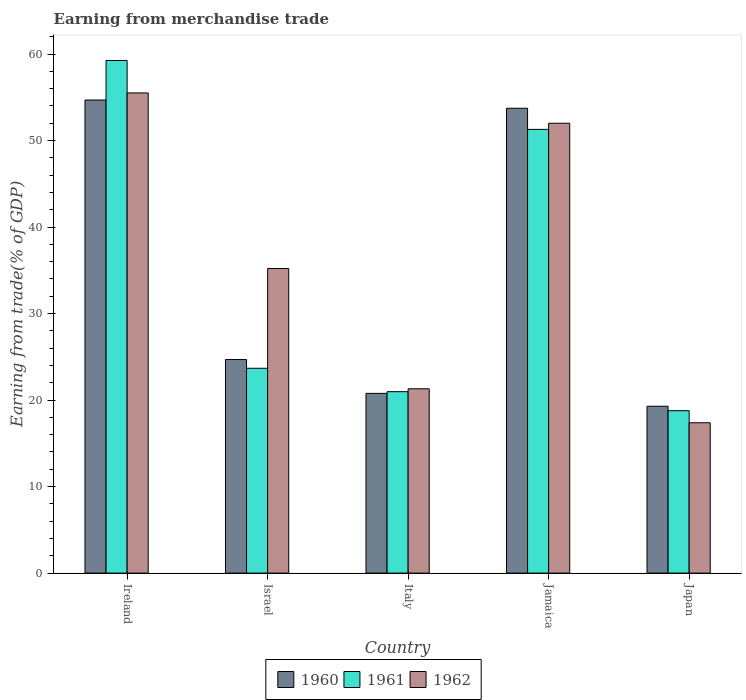How many different coloured bars are there?
Offer a terse response. 3. How many groups of bars are there?
Make the answer very short. 5. How many bars are there on the 4th tick from the left?
Provide a short and direct response. 3. In how many cases, is the number of bars for a given country not equal to the number of legend labels?
Make the answer very short. 0. What is the earnings from trade in 1962 in Israel?
Give a very brief answer. 35.21. Across all countries, what is the maximum earnings from trade in 1961?
Your answer should be compact. 59.26. Across all countries, what is the minimum earnings from trade in 1961?
Offer a terse response. 18.77. In which country was the earnings from trade in 1962 maximum?
Ensure brevity in your answer.  Ireland. What is the total earnings from trade in 1961 in the graph?
Offer a terse response. 173.98. What is the difference between the earnings from trade in 1961 in Italy and that in Japan?
Your response must be concise. 2.2. What is the difference between the earnings from trade in 1960 in Italy and the earnings from trade in 1962 in Japan?
Make the answer very short. 3.4. What is the average earnings from trade in 1962 per country?
Your response must be concise. 36.28. What is the difference between the earnings from trade of/in 1960 and earnings from trade of/in 1962 in Ireland?
Make the answer very short. -0.82. What is the ratio of the earnings from trade in 1961 in Ireland to that in Japan?
Provide a succinct answer. 3.16. What is the difference between the highest and the second highest earnings from trade in 1960?
Make the answer very short. -29.05. What is the difference between the highest and the lowest earnings from trade in 1960?
Offer a terse response. 35.4. Is the sum of the earnings from trade in 1961 in Italy and Jamaica greater than the maximum earnings from trade in 1962 across all countries?
Your response must be concise. Yes. What does the 2nd bar from the right in Japan represents?
Offer a very short reply. 1961. Is it the case that in every country, the sum of the earnings from trade in 1960 and earnings from trade in 1962 is greater than the earnings from trade in 1961?
Ensure brevity in your answer.  Yes. How many bars are there?
Offer a terse response. 15. How many countries are there in the graph?
Your response must be concise. 5. What is the difference between two consecutive major ticks on the Y-axis?
Your answer should be very brief. 10. Are the values on the major ticks of Y-axis written in scientific E-notation?
Keep it short and to the point. No. Where does the legend appear in the graph?
Keep it short and to the point. Bottom center. How many legend labels are there?
Provide a succinct answer. 3. How are the legend labels stacked?
Your answer should be compact. Horizontal. What is the title of the graph?
Offer a terse response. Earning from merchandise trade. Does "1992" appear as one of the legend labels in the graph?
Offer a terse response. No. What is the label or title of the Y-axis?
Your response must be concise. Earning from trade(% of GDP). What is the Earning from trade(% of GDP) in 1960 in Ireland?
Keep it short and to the point. 54.69. What is the Earning from trade(% of GDP) in 1961 in Ireland?
Make the answer very short. 59.26. What is the Earning from trade(% of GDP) in 1962 in Ireland?
Your answer should be compact. 55.51. What is the Earning from trade(% of GDP) in 1960 in Israel?
Offer a very short reply. 24.69. What is the Earning from trade(% of GDP) in 1961 in Israel?
Your answer should be compact. 23.68. What is the Earning from trade(% of GDP) in 1962 in Israel?
Provide a short and direct response. 35.21. What is the Earning from trade(% of GDP) of 1960 in Italy?
Keep it short and to the point. 20.78. What is the Earning from trade(% of GDP) of 1961 in Italy?
Make the answer very short. 20.97. What is the Earning from trade(% of GDP) of 1962 in Italy?
Ensure brevity in your answer.  21.31. What is the Earning from trade(% of GDP) in 1960 in Jamaica?
Keep it short and to the point. 53.74. What is the Earning from trade(% of GDP) in 1961 in Jamaica?
Ensure brevity in your answer.  51.3. What is the Earning from trade(% of GDP) of 1962 in Jamaica?
Your answer should be compact. 52. What is the Earning from trade(% of GDP) of 1960 in Japan?
Your response must be concise. 19.29. What is the Earning from trade(% of GDP) of 1961 in Japan?
Give a very brief answer. 18.77. What is the Earning from trade(% of GDP) of 1962 in Japan?
Make the answer very short. 17.38. Across all countries, what is the maximum Earning from trade(% of GDP) of 1960?
Offer a very short reply. 54.69. Across all countries, what is the maximum Earning from trade(% of GDP) of 1961?
Give a very brief answer. 59.26. Across all countries, what is the maximum Earning from trade(% of GDP) of 1962?
Offer a terse response. 55.51. Across all countries, what is the minimum Earning from trade(% of GDP) of 1960?
Offer a terse response. 19.29. Across all countries, what is the minimum Earning from trade(% of GDP) in 1961?
Give a very brief answer. 18.77. Across all countries, what is the minimum Earning from trade(% of GDP) in 1962?
Ensure brevity in your answer.  17.38. What is the total Earning from trade(% of GDP) in 1960 in the graph?
Provide a succinct answer. 173.18. What is the total Earning from trade(% of GDP) in 1961 in the graph?
Your answer should be compact. 173.98. What is the total Earning from trade(% of GDP) in 1962 in the graph?
Ensure brevity in your answer.  181.41. What is the difference between the Earning from trade(% of GDP) in 1960 in Ireland and that in Israel?
Give a very brief answer. 30. What is the difference between the Earning from trade(% of GDP) of 1961 in Ireland and that in Israel?
Make the answer very short. 35.58. What is the difference between the Earning from trade(% of GDP) in 1962 in Ireland and that in Israel?
Your response must be concise. 20.3. What is the difference between the Earning from trade(% of GDP) of 1960 in Ireland and that in Italy?
Your response must be concise. 33.91. What is the difference between the Earning from trade(% of GDP) of 1961 in Ireland and that in Italy?
Provide a short and direct response. 38.29. What is the difference between the Earning from trade(% of GDP) in 1962 in Ireland and that in Italy?
Your answer should be compact. 34.2. What is the difference between the Earning from trade(% of GDP) of 1960 in Ireland and that in Jamaica?
Your answer should be compact. 0.95. What is the difference between the Earning from trade(% of GDP) in 1961 in Ireland and that in Jamaica?
Make the answer very short. 7.96. What is the difference between the Earning from trade(% of GDP) of 1962 in Ireland and that in Jamaica?
Your answer should be very brief. 3.5. What is the difference between the Earning from trade(% of GDP) in 1960 in Ireland and that in Japan?
Offer a very short reply. 35.4. What is the difference between the Earning from trade(% of GDP) of 1961 in Ireland and that in Japan?
Give a very brief answer. 40.48. What is the difference between the Earning from trade(% of GDP) of 1962 in Ireland and that in Japan?
Keep it short and to the point. 38.13. What is the difference between the Earning from trade(% of GDP) of 1960 in Israel and that in Italy?
Offer a terse response. 3.91. What is the difference between the Earning from trade(% of GDP) of 1961 in Israel and that in Italy?
Give a very brief answer. 2.71. What is the difference between the Earning from trade(% of GDP) of 1962 in Israel and that in Italy?
Your answer should be compact. 13.9. What is the difference between the Earning from trade(% of GDP) of 1960 in Israel and that in Jamaica?
Make the answer very short. -29.05. What is the difference between the Earning from trade(% of GDP) of 1961 in Israel and that in Jamaica?
Make the answer very short. -27.62. What is the difference between the Earning from trade(% of GDP) of 1962 in Israel and that in Jamaica?
Ensure brevity in your answer.  -16.79. What is the difference between the Earning from trade(% of GDP) in 1960 in Israel and that in Japan?
Offer a very short reply. 5.4. What is the difference between the Earning from trade(% of GDP) in 1961 in Israel and that in Japan?
Provide a short and direct response. 4.9. What is the difference between the Earning from trade(% of GDP) of 1962 in Israel and that in Japan?
Keep it short and to the point. 17.83. What is the difference between the Earning from trade(% of GDP) of 1960 in Italy and that in Jamaica?
Offer a very short reply. -32.96. What is the difference between the Earning from trade(% of GDP) in 1961 in Italy and that in Jamaica?
Your response must be concise. -30.32. What is the difference between the Earning from trade(% of GDP) of 1962 in Italy and that in Jamaica?
Offer a terse response. -30.7. What is the difference between the Earning from trade(% of GDP) of 1960 in Italy and that in Japan?
Offer a very short reply. 1.49. What is the difference between the Earning from trade(% of GDP) of 1961 in Italy and that in Japan?
Provide a short and direct response. 2.2. What is the difference between the Earning from trade(% of GDP) of 1962 in Italy and that in Japan?
Provide a succinct answer. 3.93. What is the difference between the Earning from trade(% of GDP) of 1960 in Jamaica and that in Japan?
Offer a very short reply. 34.45. What is the difference between the Earning from trade(% of GDP) of 1961 in Jamaica and that in Japan?
Ensure brevity in your answer.  32.52. What is the difference between the Earning from trade(% of GDP) of 1962 in Jamaica and that in Japan?
Your answer should be very brief. 34.63. What is the difference between the Earning from trade(% of GDP) in 1960 in Ireland and the Earning from trade(% of GDP) in 1961 in Israel?
Keep it short and to the point. 31.01. What is the difference between the Earning from trade(% of GDP) in 1960 in Ireland and the Earning from trade(% of GDP) in 1962 in Israel?
Your answer should be compact. 19.48. What is the difference between the Earning from trade(% of GDP) in 1961 in Ireland and the Earning from trade(% of GDP) in 1962 in Israel?
Offer a terse response. 24.05. What is the difference between the Earning from trade(% of GDP) of 1960 in Ireland and the Earning from trade(% of GDP) of 1961 in Italy?
Keep it short and to the point. 33.72. What is the difference between the Earning from trade(% of GDP) in 1960 in Ireland and the Earning from trade(% of GDP) in 1962 in Italy?
Your answer should be compact. 33.38. What is the difference between the Earning from trade(% of GDP) of 1961 in Ireland and the Earning from trade(% of GDP) of 1962 in Italy?
Ensure brevity in your answer.  37.95. What is the difference between the Earning from trade(% of GDP) of 1960 in Ireland and the Earning from trade(% of GDP) of 1961 in Jamaica?
Give a very brief answer. 3.39. What is the difference between the Earning from trade(% of GDP) of 1960 in Ireland and the Earning from trade(% of GDP) of 1962 in Jamaica?
Give a very brief answer. 2.69. What is the difference between the Earning from trade(% of GDP) in 1961 in Ireland and the Earning from trade(% of GDP) in 1962 in Jamaica?
Provide a succinct answer. 7.25. What is the difference between the Earning from trade(% of GDP) in 1960 in Ireland and the Earning from trade(% of GDP) in 1961 in Japan?
Keep it short and to the point. 35.92. What is the difference between the Earning from trade(% of GDP) of 1960 in Ireland and the Earning from trade(% of GDP) of 1962 in Japan?
Provide a short and direct response. 37.31. What is the difference between the Earning from trade(% of GDP) in 1961 in Ireland and the Earning from trade(% of GDP) in 1962 in Japan?
Provide a succinct answer. 41.88. What is the difference between the Earning from trade(% of GDP) of 1960 in Israel and the Earning from trade(% of GDP) of 1961 in Italy?
Your answer should be very brief. 3.72. What is the difference between the Earning from trade(% of GDP) in 1960 in Israel and the Earning from trade(% of GDP) in 1962 in Italy?
Keep it short and to the point. 3.38. What is the difference between the Earning from trade(% of GDP) in 1961 in Israel and the Earning from trade(% of GDP) in 1962 in Italy?
Ensure brevity in your answer.  2.37. What is the difference between the Earning from trade(% of GDP) of 1960 in Israel and the Earning from trade(% of GDP) of 1961 in Jamaica?
Give a very brief answer. -26.61. What is the difference between the Earning from trade(% of GDP) in 1960 in Israel and the Earning from trade(% of GDP) in 1962 in Jamaica?
Give a very brief answer. -27.32. What is the difference between the Earning from trade(% of GDP) in 1961 in Israel and the Earning from trade(% of GDP) in 1962 in Jamaica?
Ensure brevity in your answer.  -28.33. What is the difference between the Earning from trade(% of GDP) of 1960 in Israel and the Earning from trade(% of GDP) of 1961 in Japan?
Provide a short and direct response. 5.91. What is the difference between the Earning from trade(% of GDP) in 1960 in Israel and the Earning from trade(% of GDP) in 1962 in Japan?
Keep it short and to the point. 7.31. What is the difference between the Earning from trade(% of GDP) in 1961 in Israel and the Earning from trade(% of GDP) in 1962 in Japan?
Offer a very short reply. 6.3. What is the difference between the Earning from trade(% of GDP) of 1960 in Italy and the Earning from trade(% of GDP) of 1961 in Jamaica?
Make the answer very short. -30.52. What is the difference between the Earning from trade(% of GDP) in 1960 in Italy and the Earning from trade(% of GDP) in 1962 in Jamaica?
Make the answer very short. -31.23. What is the difference between the Earning from trade(% of GDP) of 1961 in Italy and the Earning from trade(% of GDP) of 1962 in Jamaica?
Keep it short and to the point. -31.03. What is the difference between the Earning from trade(% of GDP) in 1960 in Italy and the Earning from trade(% of GDP) in 1961 in Japan?
Provide a succinct answer. 2. What is the difference between the Earning from trade(% of GDP) in 1960 in Italy and the Earning from trade(% of GDP) in 1962 in Japan?
Make the answer very short. 3.4. What is the difference between the Earning from trade(% of GDP) in 1961 in Italy and the Earning from trade(% of GDP) in 1962 in Japan?
Keep it short and to the point. 3.59. What is the difference between the Earning from trade(% of GDP) of 1960 in Jamaica and the Earning from trade(% of GDP) of 1961 in Japan?
Provide a short and direct response. 34.96. What is the difference between the Earning from trade(% of GDP) of 1960 in Jamaica and the Earning from trade(% of GDP) of 1962 in Japan?
Ensure brevity in your answer.  36.36. What is the difference between the Earning from trade(% of GDP) in 1961 in Jamaica and the Earning from trade(% of GDP) in 1962 in Japan?
Offer a terse response. 33.92. What is the average Earning from trade(% of GDP) of 1960 per country?
Ensure brevity in your answer.  34.64. What is the average Earning from trade(% of GDP) of 1961 per country?
Offer a terse response. 34.8. What is the average Earning from trade(% of GDP) of 1962 per country?
Offer a very short reply. 36.28. What is the difference between the Earning from trade(% of GDP) in 1960 and Earning from trade(% of GDP) in 1961 in Ireland?
Keep it short and to the point. -4.57. What is the difference between the Earning from trade(% of GDP) of 1960 and Earning from trade(% of GDP) of 1962 in Ireland?
Your response must be concise. -0.82. What is the difference between the Earning from trade(% of GDP) in 1961 and Earning from trade(% of GDP) in 1962 in Ireland?
Your answer should be very brief. 3.75. What is the difference between the Earning from trade(% of GDP) in 1960 and Earning from trade(% of GDP) in 1961 in Israel?
Give a very brief answer. 1.01. What is the difference between the Earning from trade(% of GDP) in 1960 and Earning from trade(% of GDP) in 1962 in Israel?
Keep it short and to the point. -10.52. What is the difference between the Earning from trade(% of GDP) of 1961 and Earning from trade(% of GDP) of 1962 in Israel?
Give a very brief answer. -11.53. What is the difference between the Earning from trade(% of GDP) of 1960 and Earning from trade(% of GDP) of 1961 in Italy?
Keep it short and to the point. -0.2. What is the difference between the Earning from trade(% of GDP) in 1960 and Earning from trade(% of GDP) in 1962 in Italy?
Make the answer very short. -0.53. What is the difference between the Earning from trade(% of GDP) of 1961 and Earning from trade(% of GDP) of 1962 in Italy?
Your response must be concise. -0.34. What is the difference between the Earning from trade(% of GDP) in 1960 and Earning from trade(% of GDP) in 1961 in Jamaica?
Offer a very short reply. 2.44. What is the difference between the Earning from trade(% of GDP) in 1960 and Earning from trade(% of GDP) in 1962 in Jamaica?
Offer a terse response. 1.73. What is the difference between the Earning from trade(% of GDP) of 1961 and Earning from trade(% of GDP) of 1962 in Jamaica?
Keep it short and to the point. -0.71. What is the difference between the Earning from trade(% of GDP) in 1960 and Earning from trade(% of GDP) in 1961 in Japan?
Give a very brief answer. 0.51. What is the difference between the Earning from trade(% of GDP) of 1960 and Earning from trade(% of GDP) of 1962 in Japan?
Provide a succinct answer. 1.91. What is the difference between the Earning from trade(% of GDP) of 1961 and Earning from trade(% of GDP) of 1962 in Japan?
Offer a terse response. 1.4. What is the ratio of the Earning from trade(% of GDP) of 1960 in Ireland to that in Israel?
Your response must be concise. 2.22. What is the ratio of the Earning from trade(% of GDP) in 1961 in Ireland to that in Israel?
Keep it short and to the point. 2.5. What is the ratio of the Earning from trade(% of GDP) in 1962 in Ireland to that in Israel?
Your answer should be compact. 1.58. What is the ratio of the Earning from trade(% of GDP) of 1960 in Ireland to that in Italy?
Your response must be concise. 2.63. What is the ratio of the Earning from trade(% of GDP) of 1961 in Ireland to that in Italy?
Your answer should be compact. 2.83. What is the ratio of the Earning from trade(% of GDP) in 1962 in Ireland to that in Italy?
Ensure brevity in your answer.  2.6. What is the ratio of the Earning from trade(% of GDP) of 1960 in Ireland to that in Jamaica?
Offer a terse response. 1.02. What is the ratio of the Earning from trade(% of GDP) in 1961 in Ireland to that in Jamaica?
Ensure brevity in your answer.  1.16. What is the ratio of the Earning from trade(% of GDP) of 1962 in Ireland to that in Jamaica?
Your answer should be very brief. 1.07. What is the ratio of the Earning from trade(% of GDP) in 1960 in Ireland to that in Japan?
Ensure brevity in your answer.  2.84. What is the ratio of the Earning from trade(% of GDP) of 1961 in Ireland to that in Japan?
Offer a very short reply. 3.16. What is the ratio of the Earning from trade(% of GDP) in 1962 in Ireland to that in Japan?
Offer a terse response. 3.19. What is the ratio of the Earning from trade(% of GDP) in 1960 in Israel to that in Italy?
Provide a short and direct response. 1.19. What is the ratio of the Earning from trade(% of GDP) of 1961 in Israel to that in Italy?
Provide a succinct answer. 1.13. What is the ratio of the Earning from trade(% of GDP) in 1962 in Israel to that in Italy?
Ensure brevity in your answer.  1.65. What is the ratio of the Earning from trade(% of GDP) in 1960 in Israel to that in Jamaica?
Offer a very short reply. 0.46. What is the ratio of the Earning from trade(% of GDP) of 1961 in Israel to that in Jamaica?
Offer a terse response. 0.46. What is the ratio of the Earning from trade(% of GDP) of 1962 in Israel to that in Jamaica?
Ensure brevity in your answer.  0.68. What is the ratio of the Earning from trade(% of GDP) in 1960 in Israel to that in Japan?
Provide a short and direct response. 1.28. What is the ratio of the Earning from trade(% of GDP) in 1961 in Israel to that in Japan?
Your answer should be compact. 1.26. What is the ratio of the Earning from trade(% of GDP) of 1962 in Israel to that in Japan?
Give a very brief answer. 2.03. What is the ratio of the Earning from trade(% of GDP) in 1960 in Italy to that in Jamaica?
Offer a terse response. 0.39. What is the ratio of the Earning from trade(% of GDP) of 1961 in Italy to that in Jamaica?
Your answer should be very brief. 0.41. What is the ratio of the Earning from trade(% of GDP) in 1962 in Italy to that in Jamaica?
Make the answer very short. 0.41. What is the ratio of the Earning from trade(% of GDP) in 1960 in Italy to that in Japan?
Offer a terse response. 1.08. What is the ratio of the Earning from trade(% of GDP) in 1961 in Italy to that in Japan?
Offer a very short reply. 1.12. What is the ratio of the Earning from trade(% of GDP) in 1962 in Italy to that in Japan?
Your answer should be very brief. 1.23. What is the ratio of the Earning from trade(% of GDP) in 1960 in Jamaica to that in Japan?
Provide a short and direct response. 2.79. What is the ratio of the Earning from trade(% of GDP) in 1961 in Jamaica to that in Japan?
Make the answer very short. 2.73. What is the ratio of the Earning from trade(% of GDP) in 1962 in Jamaica to that in Japan?
Ensure brevity in your answer.  2.99. What is the difference between the highest and the second highest Earning from trade(% of GDP) of 1960?
Your response must be concise. 0.95. What is the difference between the highest and the second highest Earning from trade(% of GDP) in 1961?
Offer a terse response. 7.96. What is the difference between the highest and the second highest Earning from trade(% of GDP) in 1962?
Keep it short and to the point. 3.5. What is the difference between the highest and the lowest Earning from trade(% of GDP) of 1960?
Offer a very short reply. 35.4. What is the difference between the highest and the lowest Earning from trade(% of GDP) in 1961?
Keep it short and to the point. 40.48. What is the difference between the highest and the lowest Earning from trade(% of GDP) of 1962?
Keep it short and to the point. 38.13. 